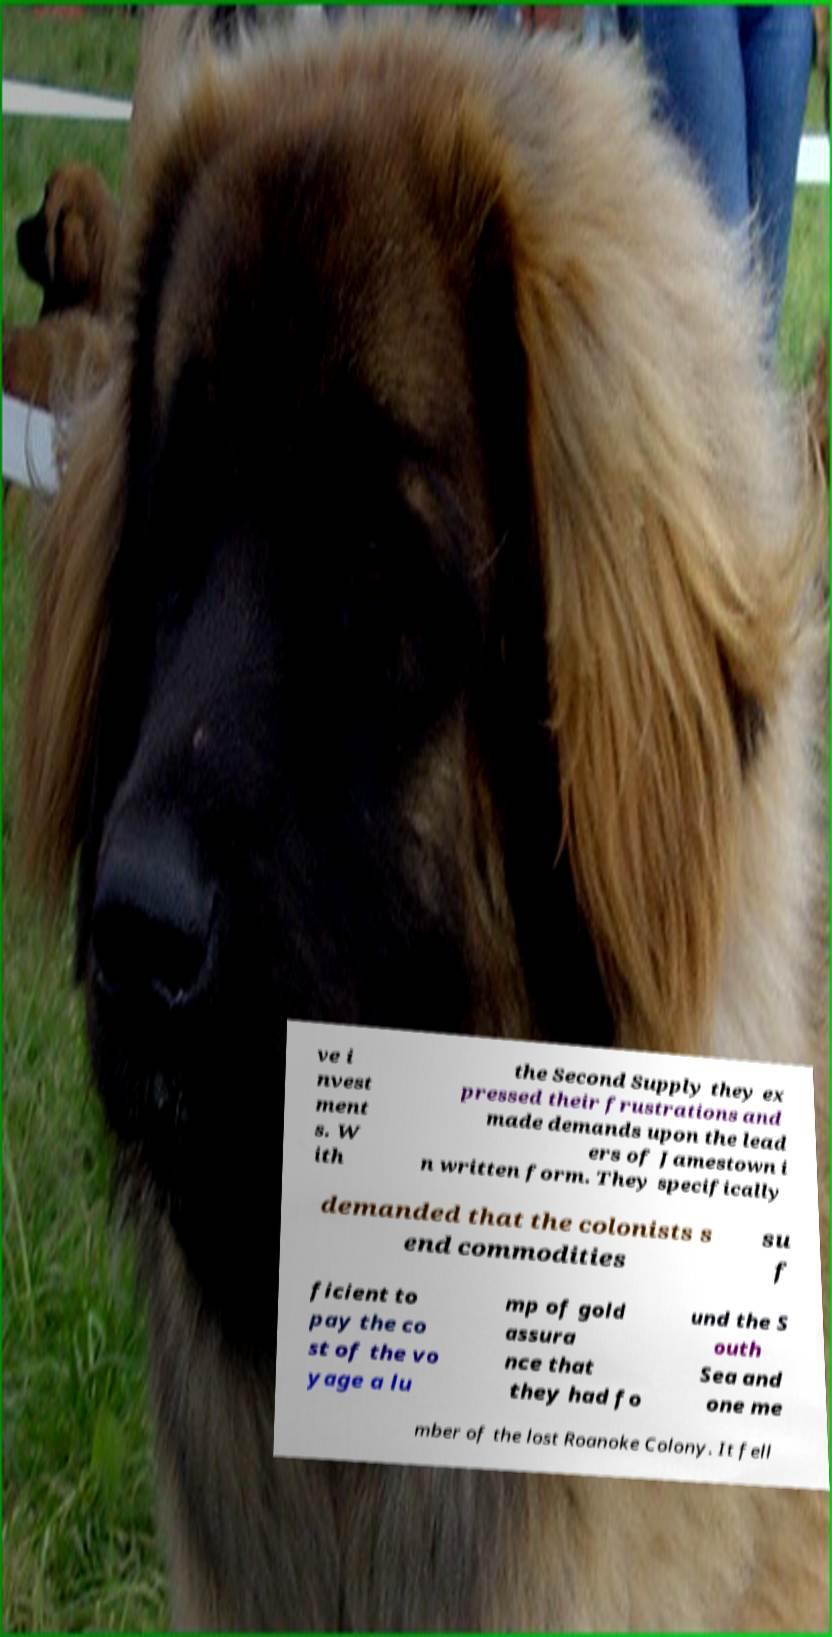For documentation purposes, I need the text within this image transcribed. Could you provide that? ve i nvest ment s. W ith the Second Supply they ex pressed their frustrations and made demands upon the lead ers of Jamestown i n written form. They specifically demanded that the colonists s end commodities su f ficient to pay the co st of the vo yage a lu mp of gold assura nce that they had fo und the S outh Sea and one me mber of the lost Roanoke Colony. It fell 